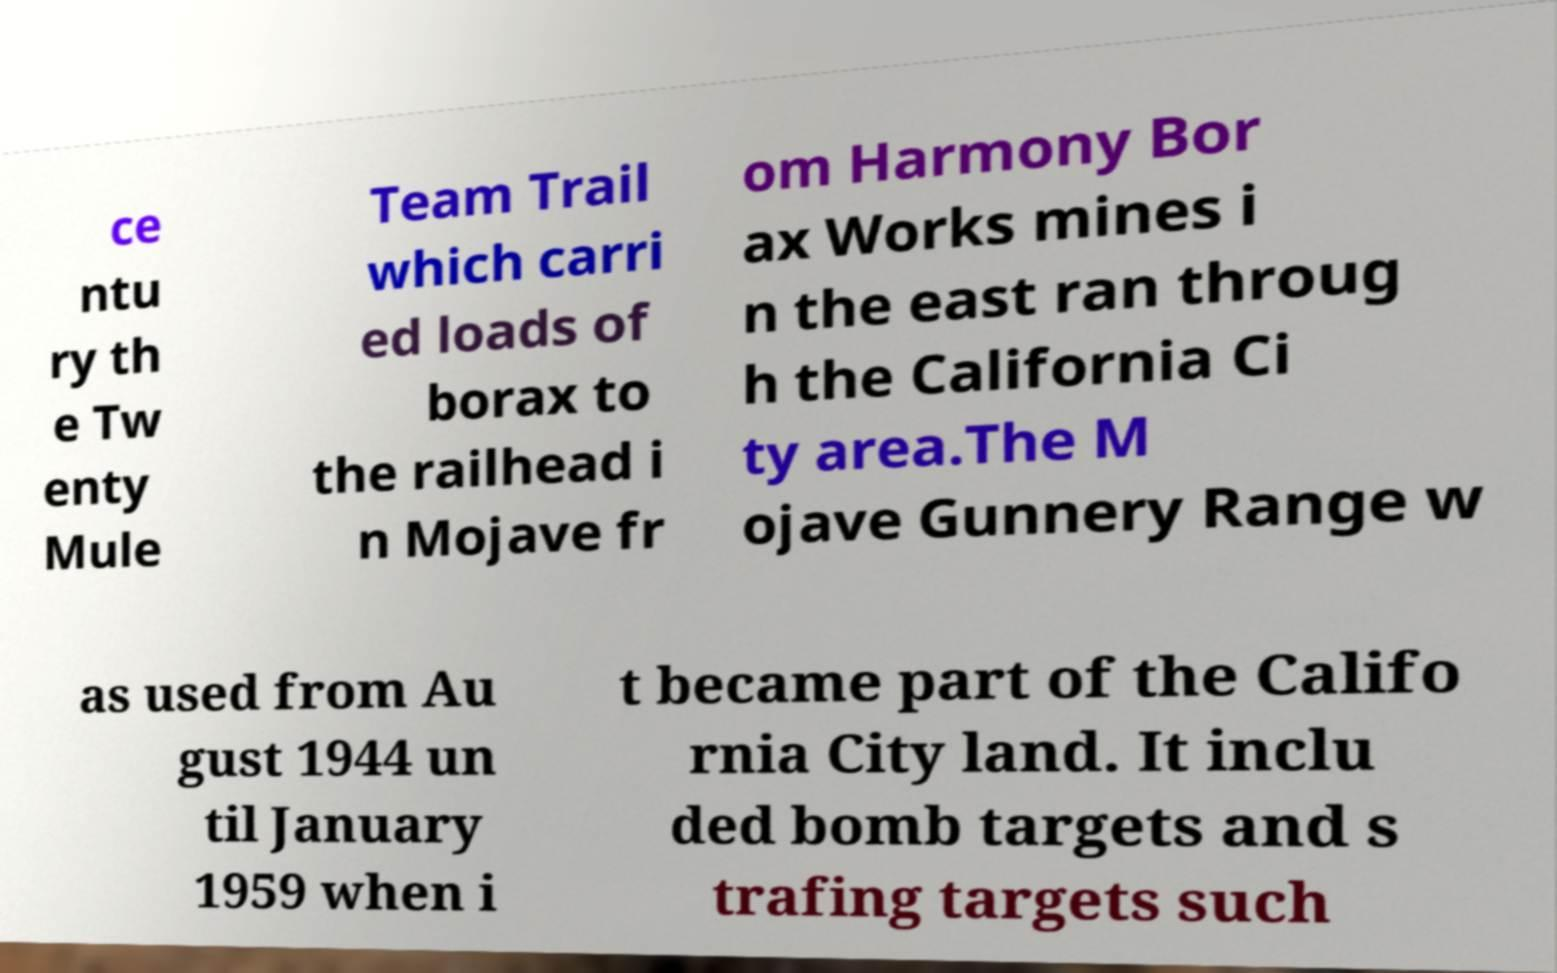For documentation purposes, I need the text within this image transcribed. Could you provide that? ce ntu ry th e Tw enty Mule Team Trail which carri ed loads of borax to the railhead i n Mojave fr om Harmony Bor ax Works mines i n the east ran throug h the California Ci ty area.The M ojave Gunnery Range w as used from Au gust 1944 un til January 1959 when i t became part of the Califo rnia City land. It inclu ded bomb targets and s trafing targets such 